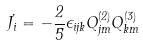Convert formula to latex. <formula><loc_0><loc_0><loc_500><loc_500>\dot { J _ { i } } = - \frac { 2 } { 5 } \epsilon _ { i j k } Q _ { j m } ^ { ( 2 ) } Q _ { k m } ^ { ( 3 ) }</formula> 